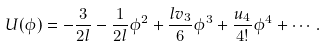Convert formula to latex. <formula><loc_0><loc_0><loc_500><loc_500>U ( \phi ) = - \frac { 3 } { 2 l } - \frac { 1 } { 2 l } \phi ^ { 2 } + \frac { l v _ { 3 } } { 6 } \phi ^ { 3 } + \frac { u _ { 4 } } { 4 ! } \phi ^ { 4 } + \cdots .</formula> 